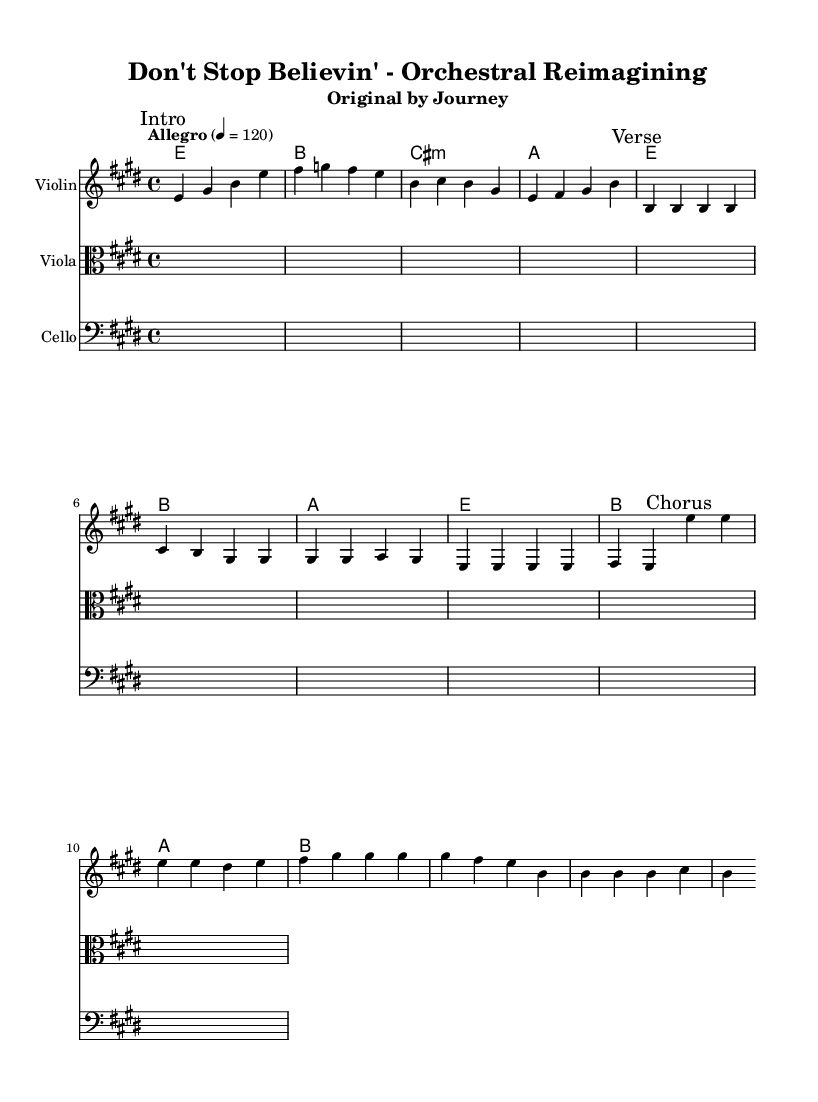What is the key signature of this music? The key signature is E major, which has four sharps (F#, C#, G#, D#).
Answer: E major What is the time signature of this music? The time signature listed is 4/4, indicating there are four beats in each measure.
Answer: 4/4 What is the tempo marking for this piece? The tempo marking "Allegro" indicates a fast tempo, specifically set at 120 beats per minute.
Answer: Allegro How many measures are in the intro melody? The intro melody consists of four measures, as indicated by the layout of the notes.
Answer: 4 What is the name of the original artist for this piece? The original artist listed in the header is Journey, as mentioned in the subtitle.
Answer: Journey Which instrument is marked with "Intro" in the sheet music? The "Intro" marking is found in the Violin staff, where the intro melody begins.
Answer: Violin What is the musical form of the piece suggested by the markings? The piece follows a verse-chorus structure, as indicated by the markings for "Verse" and "Chorus."
Answer: Verse-Chorus 